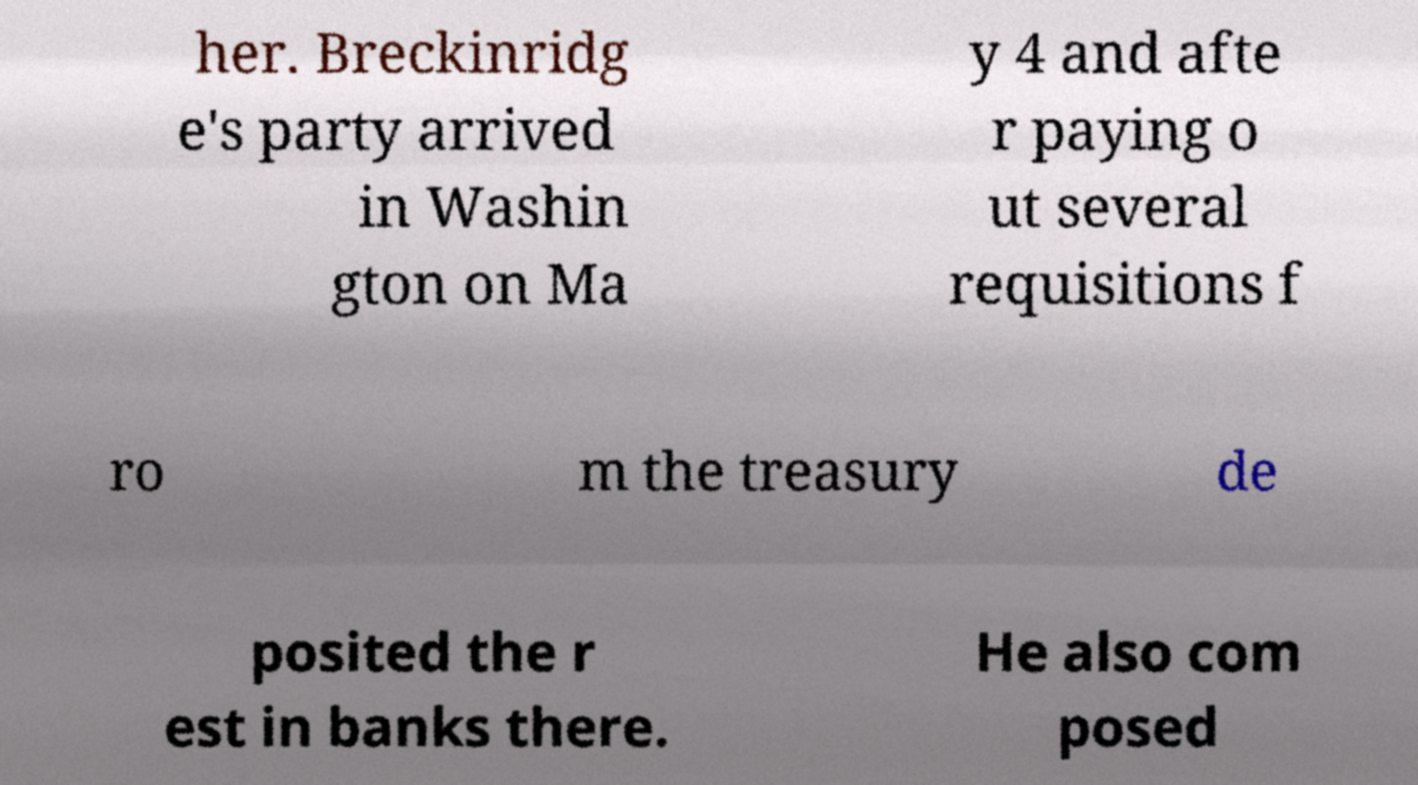Can you read and provide the text displayed in the image?This photo seems to have some interesting text. Can you extract and type it out for me? her. Breckinridg e's party arrived in Washin gton on Ma y 4 and afte r paying o ut several requisitions f ro m the treasury de posited the r est in banks there. He also com posed 